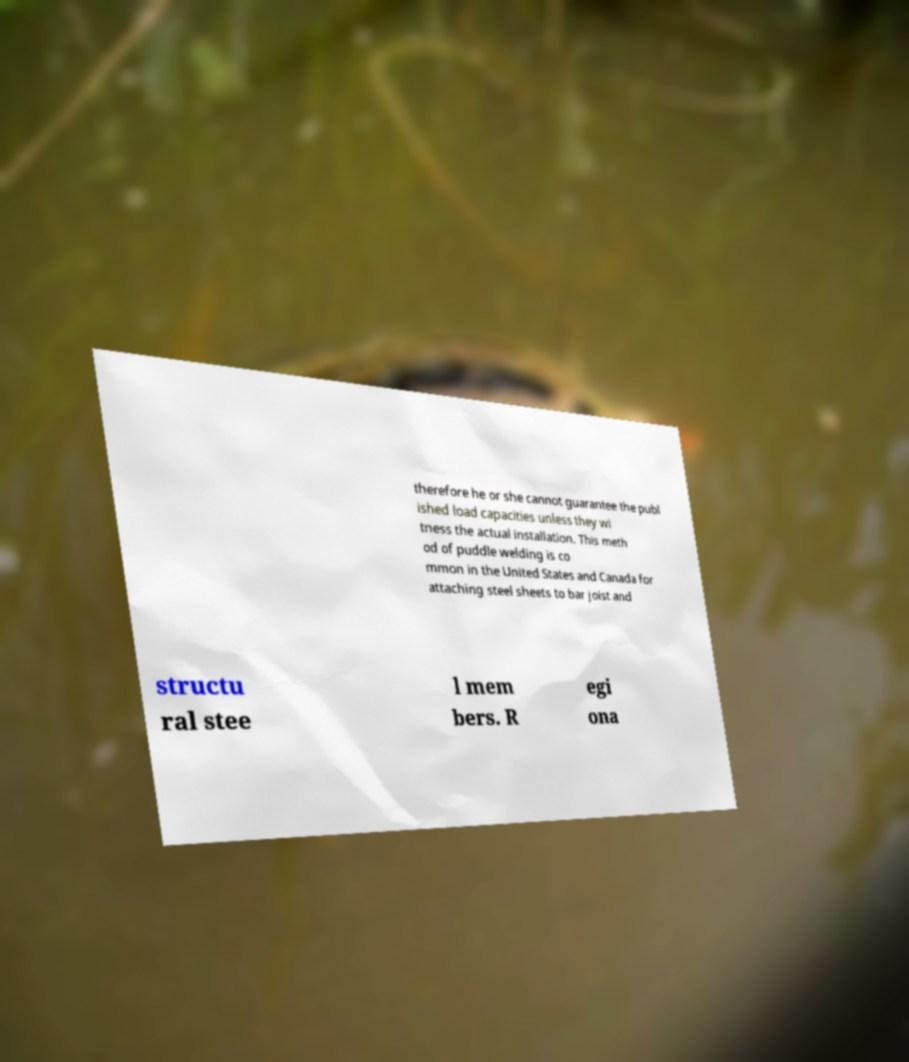Could you assist in decoding the text presented in this image and type it out clearly? therefore he or she cannot guarantee the publ ished load capacities unless they wi tness the actual installation. This meth od of puddle welding is co mmon in the United States and Canada for attaching steel sheets to bar joist and structu ral stee l mem bers. R egi ona 